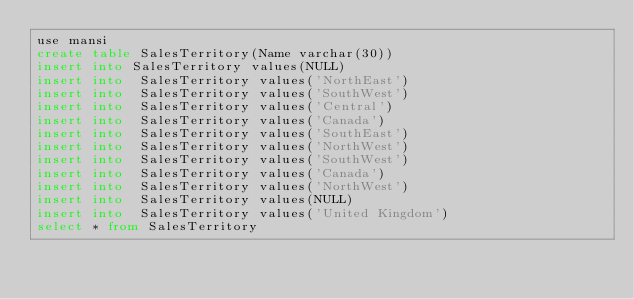Convert code to text. <code><loc_0><loc_0><loc_500><loc_500><_SQL_>use mansi
create table SalesTerritory(Name varchar(30))
insert into SalesTerritory values(NULL)
insert into  SalesTerritory values('NorthEast')
insert into  SalesTerritory values('SouthWest')
insert into  SalesTerritory values('Central')
insert into  SalesTerritory values('Canada')
insert into  SalesTerritory values('SouthEast')
insert into  SalesTerritory values('NorthWest')
insert into  SalesTerritory values('SouthWest')
insert into  SalesTerritory values('Canada')
insert into  SalesTerritory values('NorthWest')
insert into  SalesTerritory values(NULL)
insert into  SalesTerritory values('United Kingdom')
select * from SalesTerritory</code> 